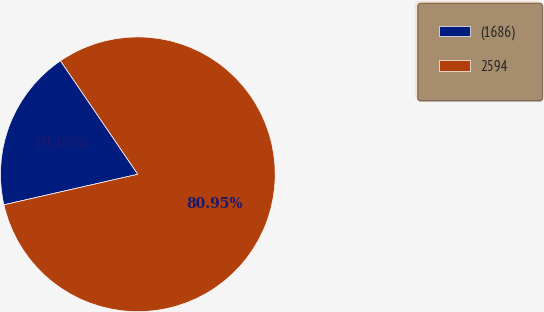Convert chart. <chart><loc_0><loc_0><loc_500><loc_500><pie_chart><fcel>(1686)<fcel>2594<nl><fcel>19.05%<fcel>80.95%<nl></chart> 